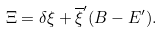Convert formula to latex. <formula><loc_0><loc_0><loc_500><loc_500>\Xi = \delta \xi + \overline { \xi } ^ { \prime } ( B - E ^ { \prime } ) .</formula> 